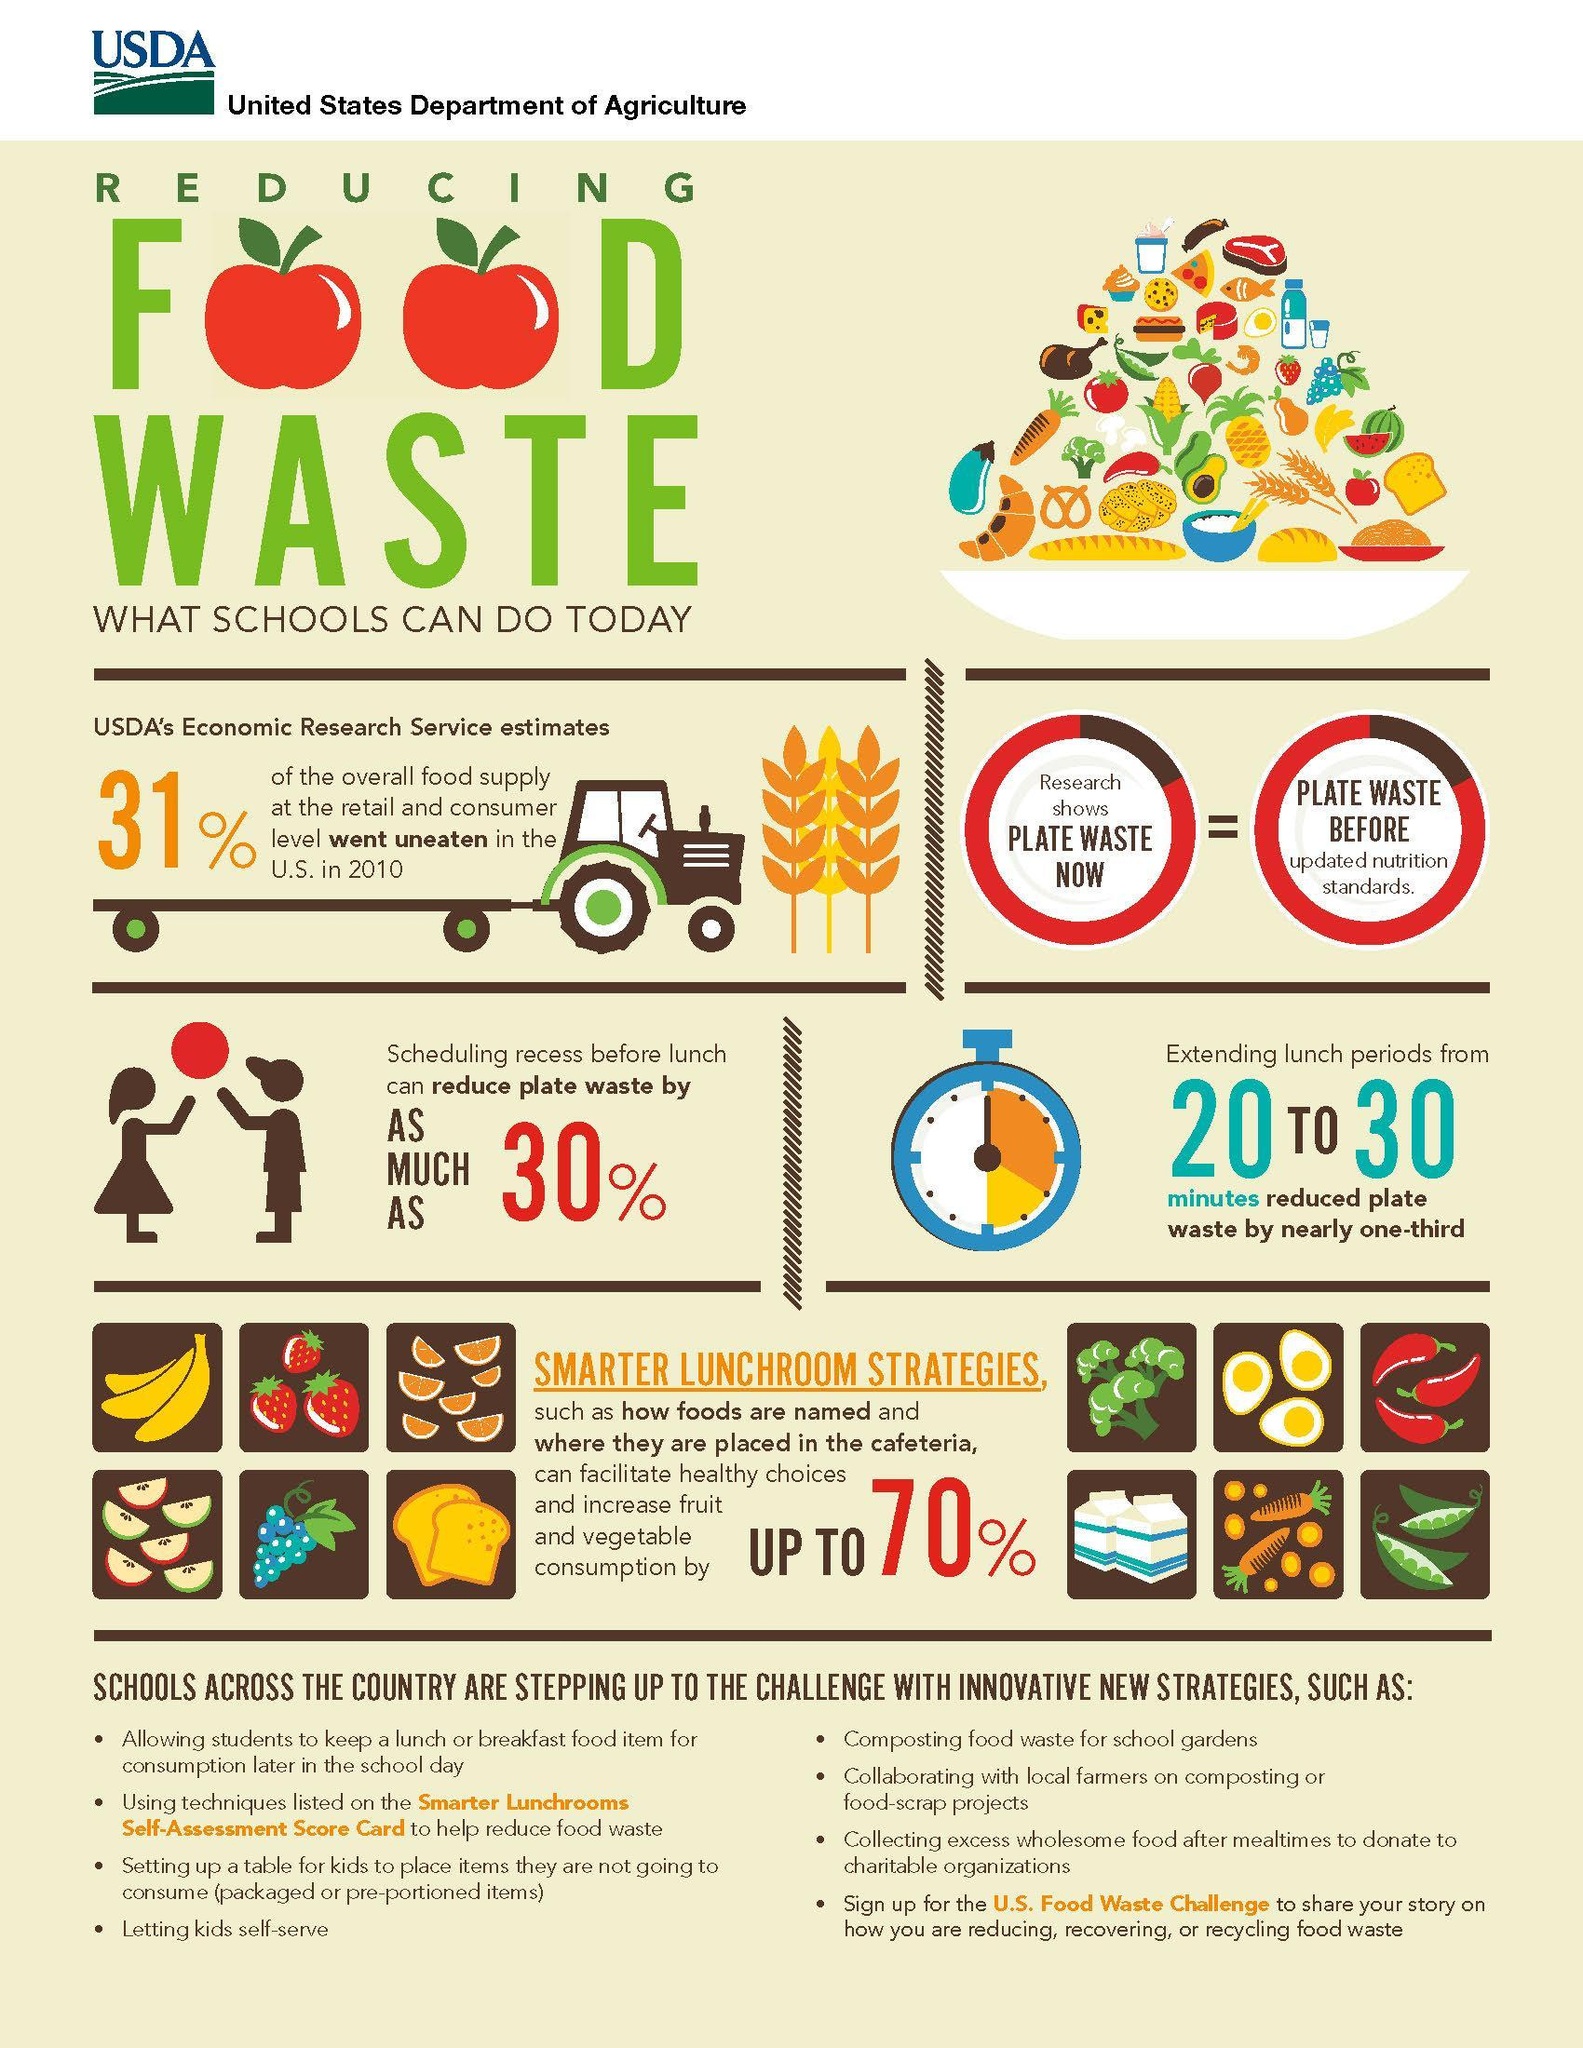What percent of the overall food supply at the retail & consumer level went uneaten in the U.S. in 2010?
Answer the question with a short phrase. 31% 